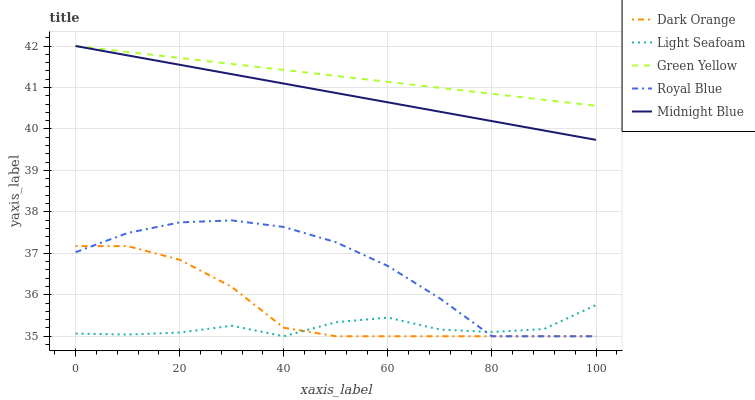Does Light Seafoam have the minimum area under the curve?
Answer yes or no. Yes. Does Green Yellow have the maximum area under the curve?
Answer yes or no. Yes. Does Green Yellow have the minimum area under the curve?
Answer yes or no. No. Does Light Seafoam have the maximum area under the curve?
Answer yes or no. No. Is Green Yellow the smoothest?
Answer yes or no. Yes. Is Light Seafoam the roughest?
Answer yes or no. Yes. Is Light Seafoam the smoothest?
Answer yes or no. No. Is Green Yellow the roughest?
Answer yes or no. No. Does Green Yellow have the lowest value?
Answer yes or no. No. Does Midnight Blue have the highest value?
Answer yes or no. Yes. Does Light Seafoam have the highest value?
Answer yes or no. No. Is Light Seafoam less than Midnight Blue?
Answer yes or no. Yes. Is Midnight Blue greater than Royal Blue?
Answer yes or no. Yes. Does Royal Blue intersect Light Seafoam?
Answer yes or no. Yes. Is Royal Blue less than Light Seafoam?
Answer yes or no. No. Is Royal Blue greater than Light Seafoam?
Answer yes or no. No. Does Light Seafoam intersect Midnight Blue?
Answer yes or no. No. 